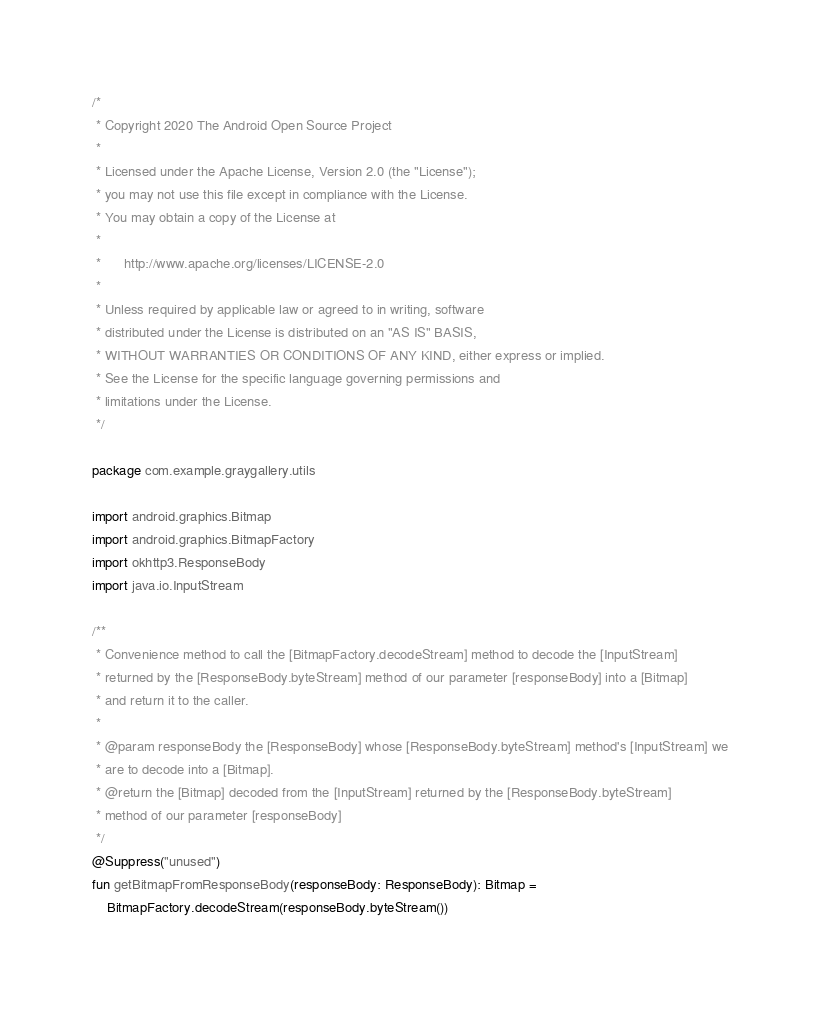Convert code to text. <code><loc_0><loc_0><loc_500><loc_500><_Kotlin_>/*
 * Copyright 2020 The Android Open Source Project
 *
 * Licensed under the Apache License, Version 2.0 (the "License");
 * you may not use this file except in compliance with the License.
 * You may obtain a copy of the License at
 *
 *      http://www.apache.org/licenses/LICENSE-2.0
 *
 * Unless required by applicable law or agreed to in writing, software
 * distributed under the License is distributed on an "AS IS" BASIS,
 * WITHOUT WARRANTIES OR CONDITIONS OF ANY KIND, either express or implied.
 * See the License for the specific language governing permissions and
 * limitations under the License.
 */

package com.example.graygallery.utils

import android.graphics.Bitmap
import android.graphics.BitmapFactory
import okhttp3.ResponseBody
import java.io.InputStream

/**
 * Convenience method to call the [BitmapFactory.decodeStream] method to decode the [InputStream]
 * returned by the [ResponseBody.byteStream] method of our parameter [responseBody] into a [Bitmap]
 * and return it to the caller.
 *
 * @param responseBody the [ResponseBody] whose [ResponseBody.byteStream] method's [InputStream] we
 * are to decode into a [Bitmap].
 * @return the [Bitmap] decoded from the [InputStream] returned by the [ResponseBody.byteStream]
 * method of our parameter [responseBody]
 */
@Suppress("unused")
fun getBitmapFromResponseBody(responseBody: ResponseBody): Bitmap =
    BitmapFactory.decodeStream(responseBody.byteStream())</code> 